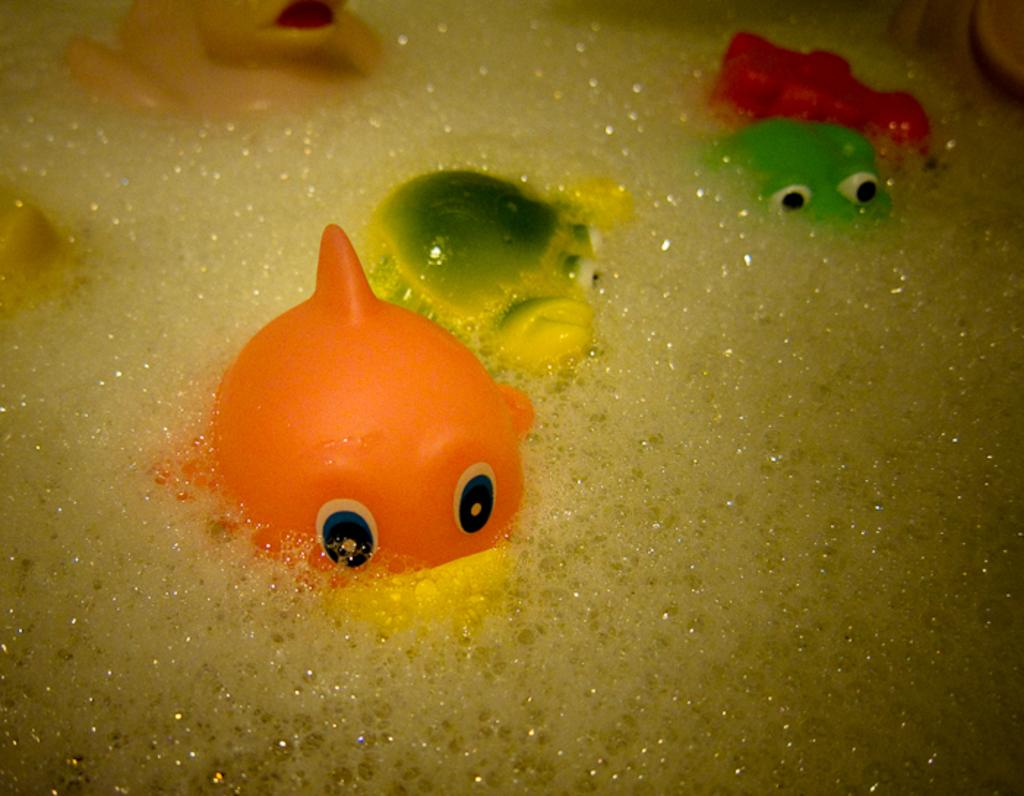What type of toys are present in the image? There are toy fishes in the image. Where are the toy fishes located? The toy fishes are in the water. What type of sugar is being used to feed the worms in the image? There are no worms or sugar present in the image; it features toy fishes in the water. What type of suit is the person wearing while interacting with the toy fishes in the image? There is no person present in the image, only toy fishes in the water. 